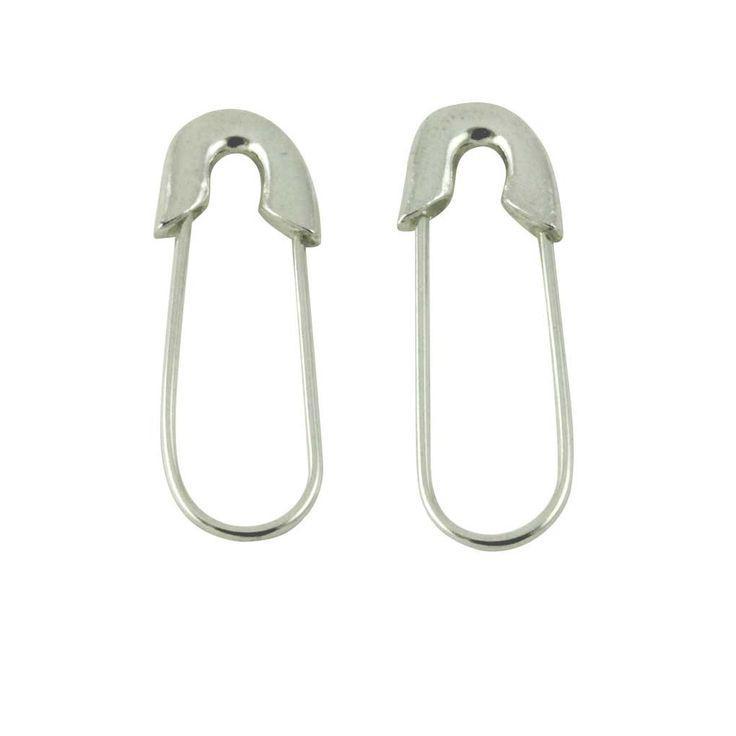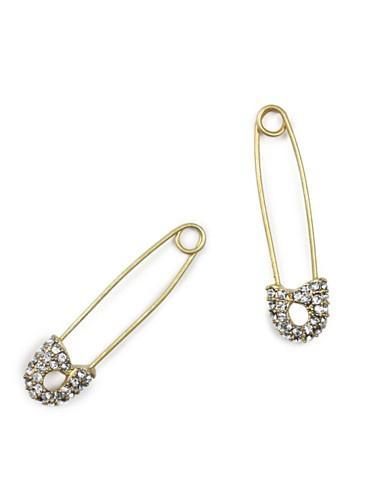The first image is the image on the left, the second image is the image on the right. For the images displayed, is the sentence "there are 4 safety pins in the image pair" factually correct? Answer yes or no. Yes. The first image is the image on the left, the second image is the image on the right. Considering the images on both sides, is "At least one image includes a pair of closed, unembellished gold safety pins displayed with the clasp end downward." valid? Answer yes or no. No. 